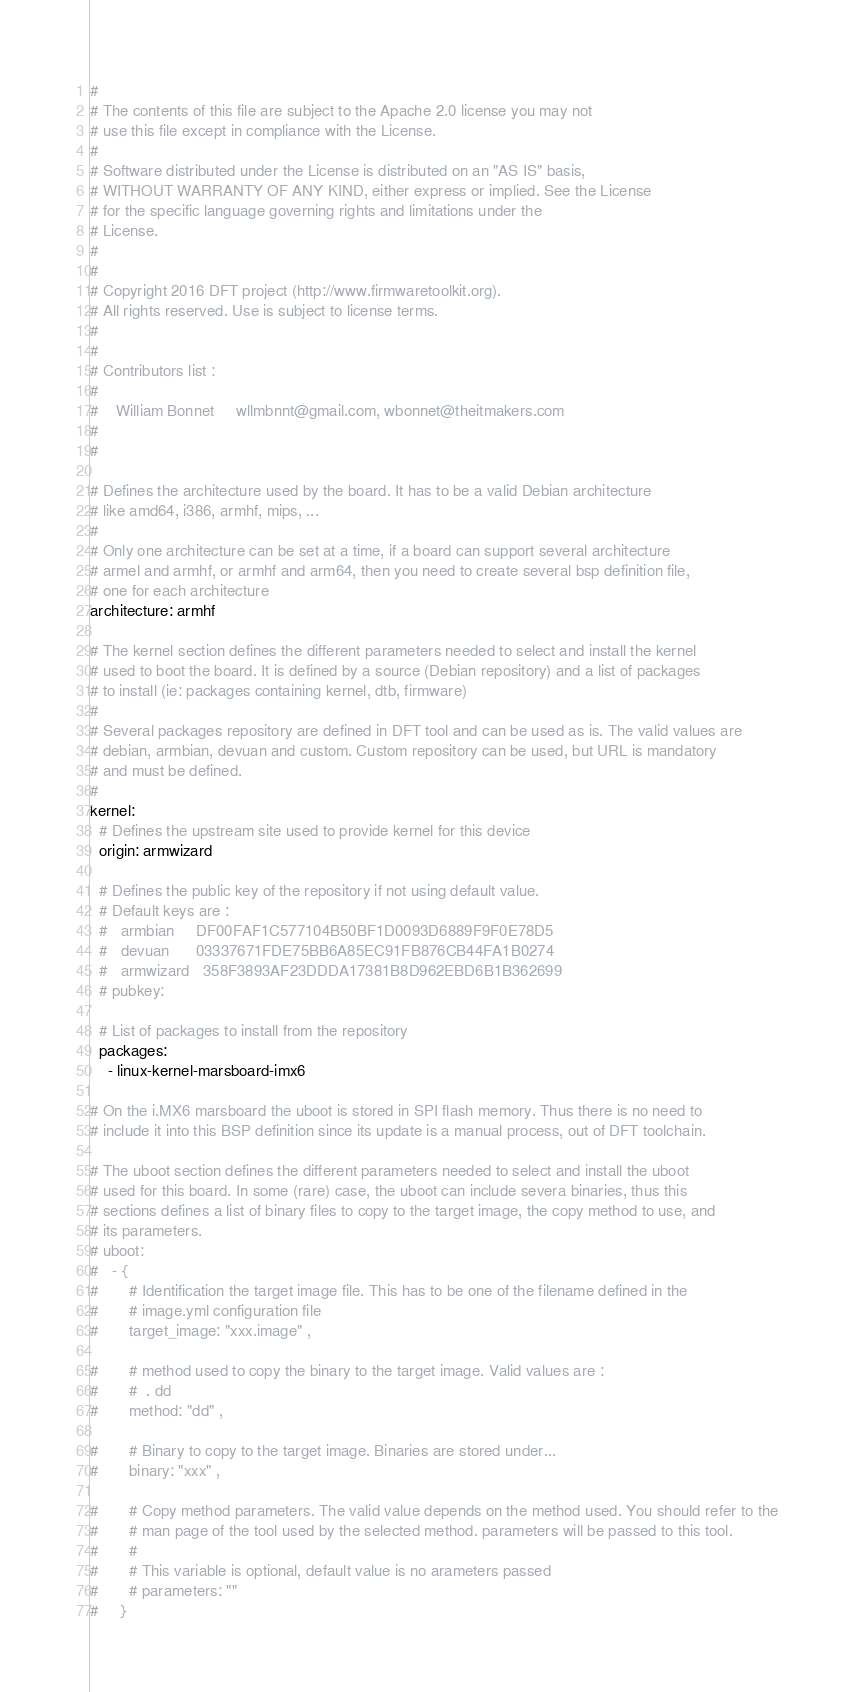<code> <loc_0><loc_0><loc_500><loc_500><_YAML_>#
# The contents of this file are subject to the Apache 2.0 license you may not
# use this file except in compliance with the License.
#
# Software distributed under the License is distributed on an "AS IS" basis,
# WITHOUT WARRANTY OF ANY KIND, either express or implied. See the License
# for the specific language governing rights and limitations under the
# License.
#
#
# Copyright 2016 DFT project (http://www.firmwaretoolkit.org).
# All rights reserved. Use is subject to license terms.
#
#
# Contributors list :
#
#    William Bonnet     wllmbnnt@gmail.com, wbonnet@theitmakers.com
#
#

# Defines the architecture used by the board. It has to be a valid Debian architecture
# like amd64, i386, armhf, mips, ...
#
# Only one architecture can be set at a time, if a board can support several architecture
# armel and armhf, or armhf and arm64, then you need to create several bsp definition file,
# one for each architecture
architecture: armhf

# The kernel section defines the different parameters needed to select and install the kernel
# used to boot the board. It is defined by a source (Debian repository) and a list of packages
# to install (ie: packages containing kernel, dtb, firmware)
#
# Several packages repository are defined in DFT tool and can be used as is. The valid values are
# debian, armbian, devuan and custom. Custom repository can be used, but URL is mandatory
# and must be defined.
#
kernel:
  # Defines the upstream site used to provide kernel for this device
  origin: armwizard

  # Defines the public key of the repository if not using default value.
  # Default keys are :
  #   armbian     DF00FAF1C577104B50BF1D0093D6889F9F0E78D5
  #   devuan      03337671FDE75BB6A85EC91FB876CB44FA1B0274
  #   armwizard   358F3893AF23DDDA17381B8D962EBD6B1B362699
  # pubkey:

  # List of packages to install from the repository
  packages:
    - linux-kernel-marsboard-imx6

# On the i.MX6 marsboard the uboot is stored in SPI flash memory. Thus there is no need to
# include it into this BSP definition since its update is a manual process, out of DFT toolchain.

# The uboot section defines the different parameters needed to select and install the uboot
# used for this board. In some (rare) case, the uboot can include severa binaries, thus this
# sections defines a list of binary files to copy to the target image, the copy method to use, and
# its parameters.
# uboot:
#   - {
#       # Identification the target image file. This has to be one of the filename defined in the
#       # image.yml configuration file
#       target_image: "xxx.image" ,

#       # method used to copy the binary to the target image. Valid values are :
#       #  . dd
#       method: "dd" ,

#       # Binary to copy to the target image. Binaries are stored under...
#       binary: "xxx" ,

#       # Copy method parameters. The valid value depends on the method used. You should refer to the
#       # man page of the tool used by the selected method. parameters will be passed to this tool.
#       #
#       # This variable is optional, default value is no arameters passed
#       # parameters: ""
#     }
</code> 